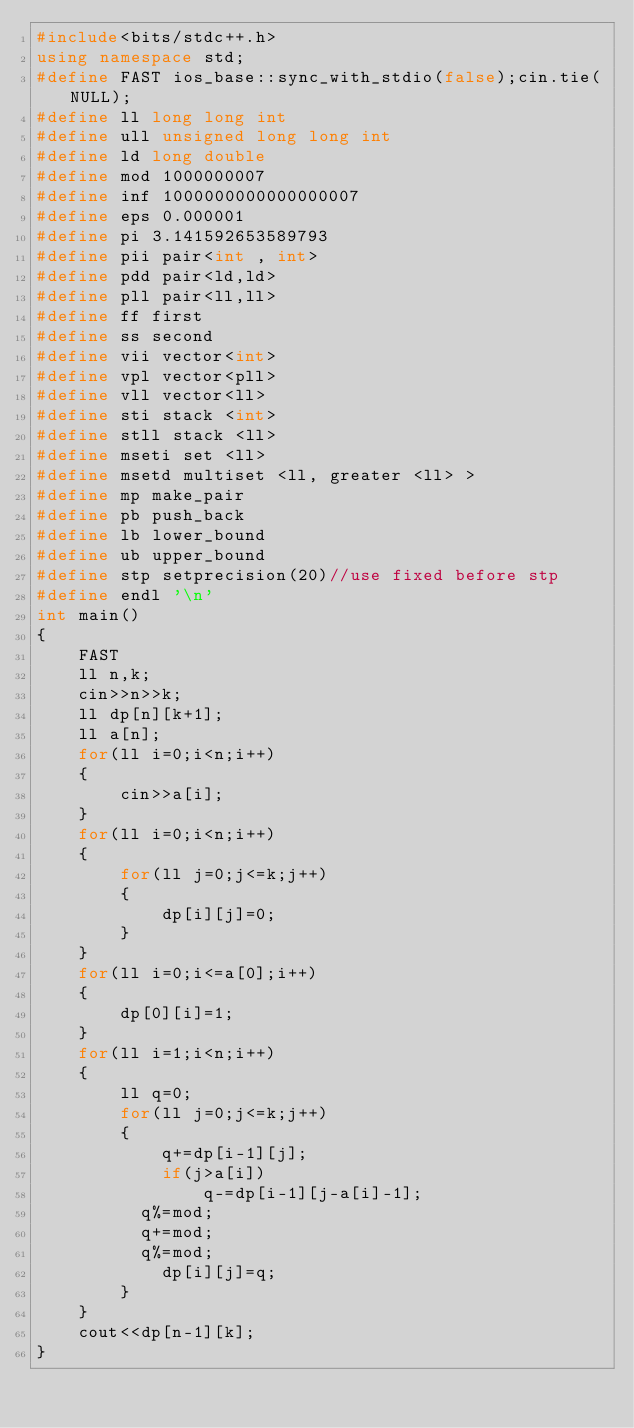Convert code to text. <code><loc_0><loc_0><loc_500><loc_500><_C++_>#include<bits/stdc++.h>
using namespace std;
#define FAST ios_base::sync_with_stdio(false);cin.tie(NULL);
#define ll long long int
#define ull unsigned long long int
#define ld long double
#define mod 1000000007
#define inf 1000000000000000007
#define eps 0.000001
#define pi 3.141592653589793
#define pii pair<int , int>
#define pdd pair<ld,ld>
#define pll pair<ll,ll>
#define ff first
#define ss second
#define vii vector<int>
#define vpl vector<pll>
#define vll vector<ll>
#define sti stack <int>
#define stll stack <ll>
#define mseti set <ll>
#define msetd multiset <ll, greater <ll> >
#define mp make_pair
#define pb push_back
#define lb lower_bound
#define ub upper_bound 
#define stp setprecision(20)//use fixed before stp
#define endl '\n'
int main()
{  
    FAST
    ll n,k;
    cin>>n>>k;
    ll dp[n][k+1];
    ll a[n];
    for(ll i=0;i<n;i++)
    {
        cin>>a[i];
    }
    for(ll i=0;i<n;i++)
    {
        for(ll j=0;j<=k;j++)
        {
            dp[i][j]=0;
        }
    }
    for(ll i=0;i<=a[0];i++)
    {
        dp[0][i]=1;
    }
    for(ll i=1;i<n;i++)
    {
        ll q=0;
        for(ll j=0;j<=k;j++)
        {
            q+=dp[i-1][j];
            if(j>a[i])
                q-=dp[i-1][j-a[i]-1];
          q%=mod;
          q+=mod;
          q%=mod;
            dp[i][j]=q;
        }
    }
    cout<<dp[n-1][k];
}</code> 